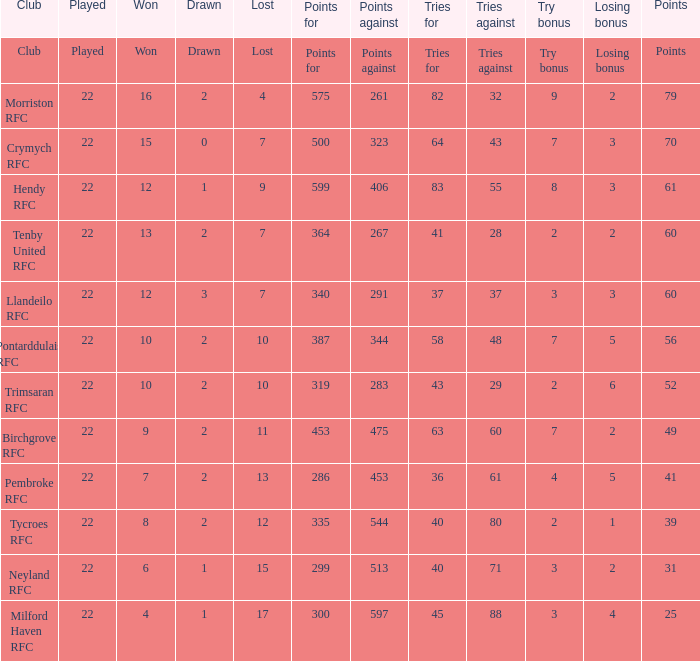 how many losing bonus with won being 10 and points against being 283 1.0. Can you parse all the data within this table? {'header': ['Club', 'Played', 'Won', 'Drawn', 'Lost', 'Points for', 'Points against', 'Tries for', 'Tries against', 'Try bonus', 'Losing bonus', 'Points'], 'rows': [['Club', 'Played', 'Won', 'Drawn', 'Lost', 'Points for', 'Points against', 'Tries for', 'Tries against', 'Try bonus', 'Losing bonus', 'Points'], ['Morriston RFC', '22', '16', '2', '4', '575', '261', '82', '32', '9', '2', '79'], ['Crymych RFC', '22', '15', '0', '7', '500', '323', '64', '43', '7', '3', '70'], ['Hendy RFC', '22', '12', '1', '9', '599', '406', '83', '55', '8', '3', '61'], ['Tenby United RFC', '22', '13', '2', '7', '364', '267', '41', '28', '2', '2', '60'], ['Llandeilo RFC', '22', '12', '3', '7', '340', '291', '37', '37', '3', '3', '60'], ['Pontarddulais RFC', '22', '10', '2', '10', '387', '344', '58', '48', '7', '5', '56'], ['Trimsaran RFC', '22', '10', '2', '10', '319', '283', '43', '29', '2', '6', '52'], ['Birchgrove RFC', '22', '9', '2', '11', '453', '475', '63', '60', '7', '2', '49'], ['Pembroke RFC', '22', '7', '2', '13', '286', '453', '36', '61', '4', '5', '41'], ['Tycroes RFC', '22', '8', '2', '12', '335', '544', '40', '80', '2', '1', '39'], ['Neyland RFC', '22', '6', '1', '15', '299', '513', '40', '71', '3', '2', '31'], ['Milford Haven RFC', '22', '4', '1', '17', '300', '597', '45', '88', '3', '4', '25']]} 